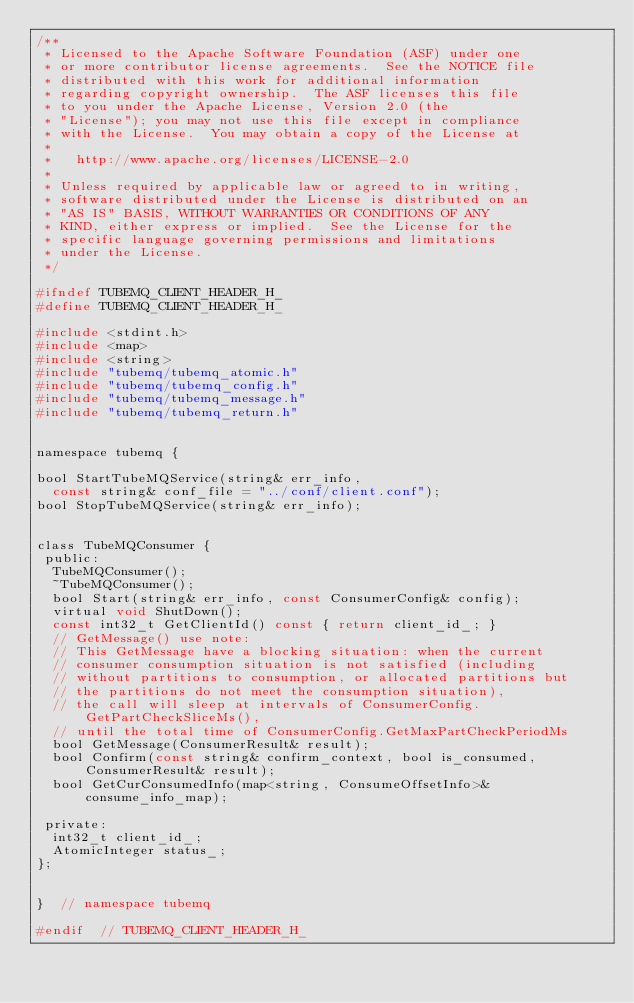Convert code to text. <code><loc_0><loc_0><loc_500><loc_500><_C_>/**
 * Licensed to the Apache Software Foundation (ASF) under one
 * or more contributor license agreements.  See the NOTICE file
 * distributed with this work for additional information
 * regarding copyright ownership.  The ASF licenses this file
 * to you under the Apache License, Version 2.0 (the
 * "License"); you may not use this file except in compliance
 * with the License.  You may obtain a copy of the License at
 *
 *   http://www.apache.org/licenses/LICENSE-2.0
 *
 * Unless required by applicable law or agreed to in writing,
 * software distributed under the License is distributed on an
 * "AS IS" BASIS, WITHOUT WARRANTIES OR CONDITIONS OF ANY
 * KIND, either express or implied.  See the License for the
 * specific language governing permissions and limitations
 * under the License.
 */

#ifndef TUBEMQ_CLIENT_HEADER_H_
#define TUBEMQ_CLIENT_HEADER_H_

#include <stdint.h>
#include <map>
#include <string>
#include "tubemq/tubemq_atomic.h"
#include "tubemq/tubemq_config.h"
#include "tubemq/tubemq_message.h"
#include "tubemq/tubemq_return.h"


namespace tubemq {

bool StartTubeMQService(string& err_info,
  const string& conf_file = "../conf/client.conf");
bool StopTubeMQService(string& err_info);


class TubeMQConsumer {
 public:
  TubeMQConsumer();
  ~TubeMQConsumer();
  bool Start(string& err_info, const ConsumerConfig& config);
  virtual void ShutDown();
  const int32_t GetClientId() const { return client_id_; }
  // GetMessage() use note:
  // This GetMessage have a blocking situation: when the current
  // consumer consumption situation is not satisfied (including
  // without partitions to consumption, or allocated partitions but
  // the partitions do not meet the consumption situation),
  // the call will sleep at intervals of ConsumerConfig.GetPartCheckSliceMs(),
  // until the total time of ConsumerConfig.GetMaxPartCheckPeriodMs
  bool GetMessage(ConsumerResult& result);
  bool Confirm(const string& confirm_context, bool is_consumed, ConsumerResult& result);
  bool GetCurConsumedInfo(map<string, ConsumeOffsetInfo>& consume_info_map);

 private:
  int32_t client_id_;
  AtomicInteger status_;
};


}  // namespace tubemq

#endif  // TUBEMQ_CLIENT_HEADER_H_

</code> 